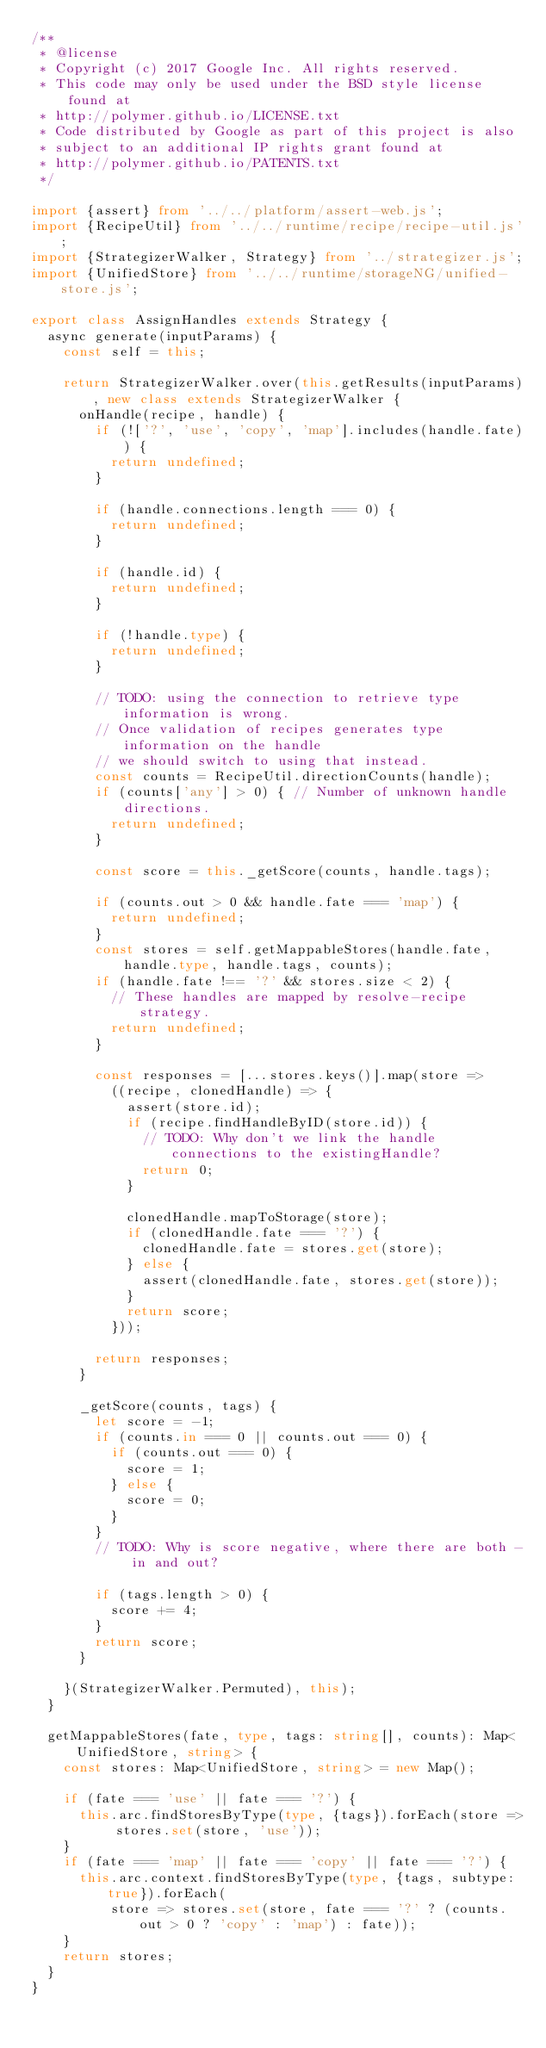<code> <loc_0><loc_0><loc_500><loc_500><_TypeScript_>/**
 * @license
 * Copyright (c) 2017 Google Inc. All rights reserved.
 * This code may only be used under the BSD style license found at
 * http://polymer.github.io/LICENSE.txt
 * Code distributed by Google as part of this project is also
 * subject to an additional IP rights grant found at
 * http://polymer.github.io/PATENTS.txt
 */

import {assert} from '../../platform/assert-web.js';
import {RecipeUtil} from '../../runtime/recipe/recipe-util.js';
import {StrategizerWalker, Strategy} from '../strategizer.js';
import {UnifiedStore} from '../../runtime/storageNG/unified-store.js';

export class AssignHandles extends Strategy {
  async generate(inputParams) {
    const self = this;

    return StrategizerWalker.over(this.getResults(inputParams), new class extends StrategizerWalker {
      onHandle(recipe, handle) {
        if (!['?', 'use', 'copy', 'map'].includes(handle.fate)) {
          return undefined;
        }

        if (handle.connections.length === 0) {
          return undefined;
        }

        if (handle.id) {
          return undefined;
        }

        if (!handle.type) {
          return undefined;
        }

        // TODO: using the connection to retrieve type information is wrong.
        // Once validation of recipes generates type information on the handle
        // we should switch to using that instead.
        const counts = RecipeUtil.directionCounts(handle);
        if (counts['any'] > 0) { // Number of unknown handle directions.
          return undefined;
        }

        const score = this._getScore(counts, handle.tags);

        if (counts.out > 0 && handle.fate === 'map') {
          return undefined;
        }
        const stores = self.getMappableStores(handle.fate, handle.type, handle.tags, counts);
        if (handle.fate !== '?' && stores.size < 2) {
          // These handles are mapped by resolve-recipe strategy.
          return undefined;
        }

        const responses = [...stores.keys()].map(store =>
          ((recipe, clonedHandle) => {
            assert(store.id);
            if (recipe.findHandleByID(store.id)) {
              // TODO: Why don't we link the handle connections to the existingHandle?
              return 0;
            }

            clonedHandle.mapToStorage(store);
            if (clonedHandle.fate === '?') {
              clonedHandle.fate = stores.get(store);
            } else {
              assert(clonedHandle.fate, stores.get(store));
            }
            return score;
          }));

        return responses;
      }

      _getScore(counts, tags) {
        let score = -1;
        if (counts.in === 0 || counts.out === 0) {
          if (counts.out === 0) {
            score = 1;
          } else {
            score = 0;
          }
        }
        // TODO: Why is score negative, where there are both - in and out?

        if (tags.length > 0) {
          score += 4;
        }
        return score;
      }

    }(StrategizerWalker.Permuted), this);
  }

  getMappableStores(fate, type, tags: string[], counts): Map<UnifiedStore, string> {
    const stores: Map<UnifiedStore, string> = new Map();

    if (fate === 'use' || fate === '?') {
      this.arc.findStoresByType(type, {tags}).forEach(store => stores.set(store, 'use'));
    }
    if (fate === 'map' || fate === 'copy' || fate === '?') {
      this.arc.context.findStoresByType(type, {tags, subtype: true}).forEach(
          store => stores.set(store, fate === '?' ? (counts.out > 0 ? 'copy' : 'map') : fate));
    }
    return stores;
  }
}
</code> 